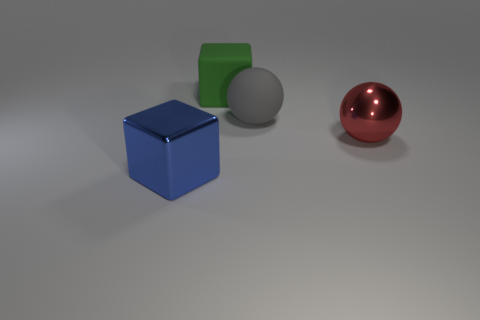What is the color of the other big object that is the same shape as the big gray object?
Your response must be concise. Red. Is the number of gray objects that are to the left of the big red sphere greater than the number of large blue things?
Provide a short and direct response. No. There is a green thing; does it have the same shape as the object that is on the left side of the big green thing?
Your response must be concise. Yes. What size is the other thing that is the same shape as the large gray object?
Your answer should be compact. Large. Are there more matte cubes than large blue rubber balls?
Your answer should be very brief. Yes. Is the gray thing the same shape as the red metallic object?
Offer a terse response. Yes. There is a big sphere to the left of the metallic thing on the right side of the large gray rubber thing; what is its material?
Make the answer very short. Rubber. Is the blue object the same size as the red shiny thing?
Provide a succinct answer. Yes. There is a big red thing that is behind the blue metallic block; is there a thing that is behind it?
Your answer should be compact. Yes. There is a metallic object that is left of the gray sphere; what is its shape?
Keep it short and to the point. Cube. 